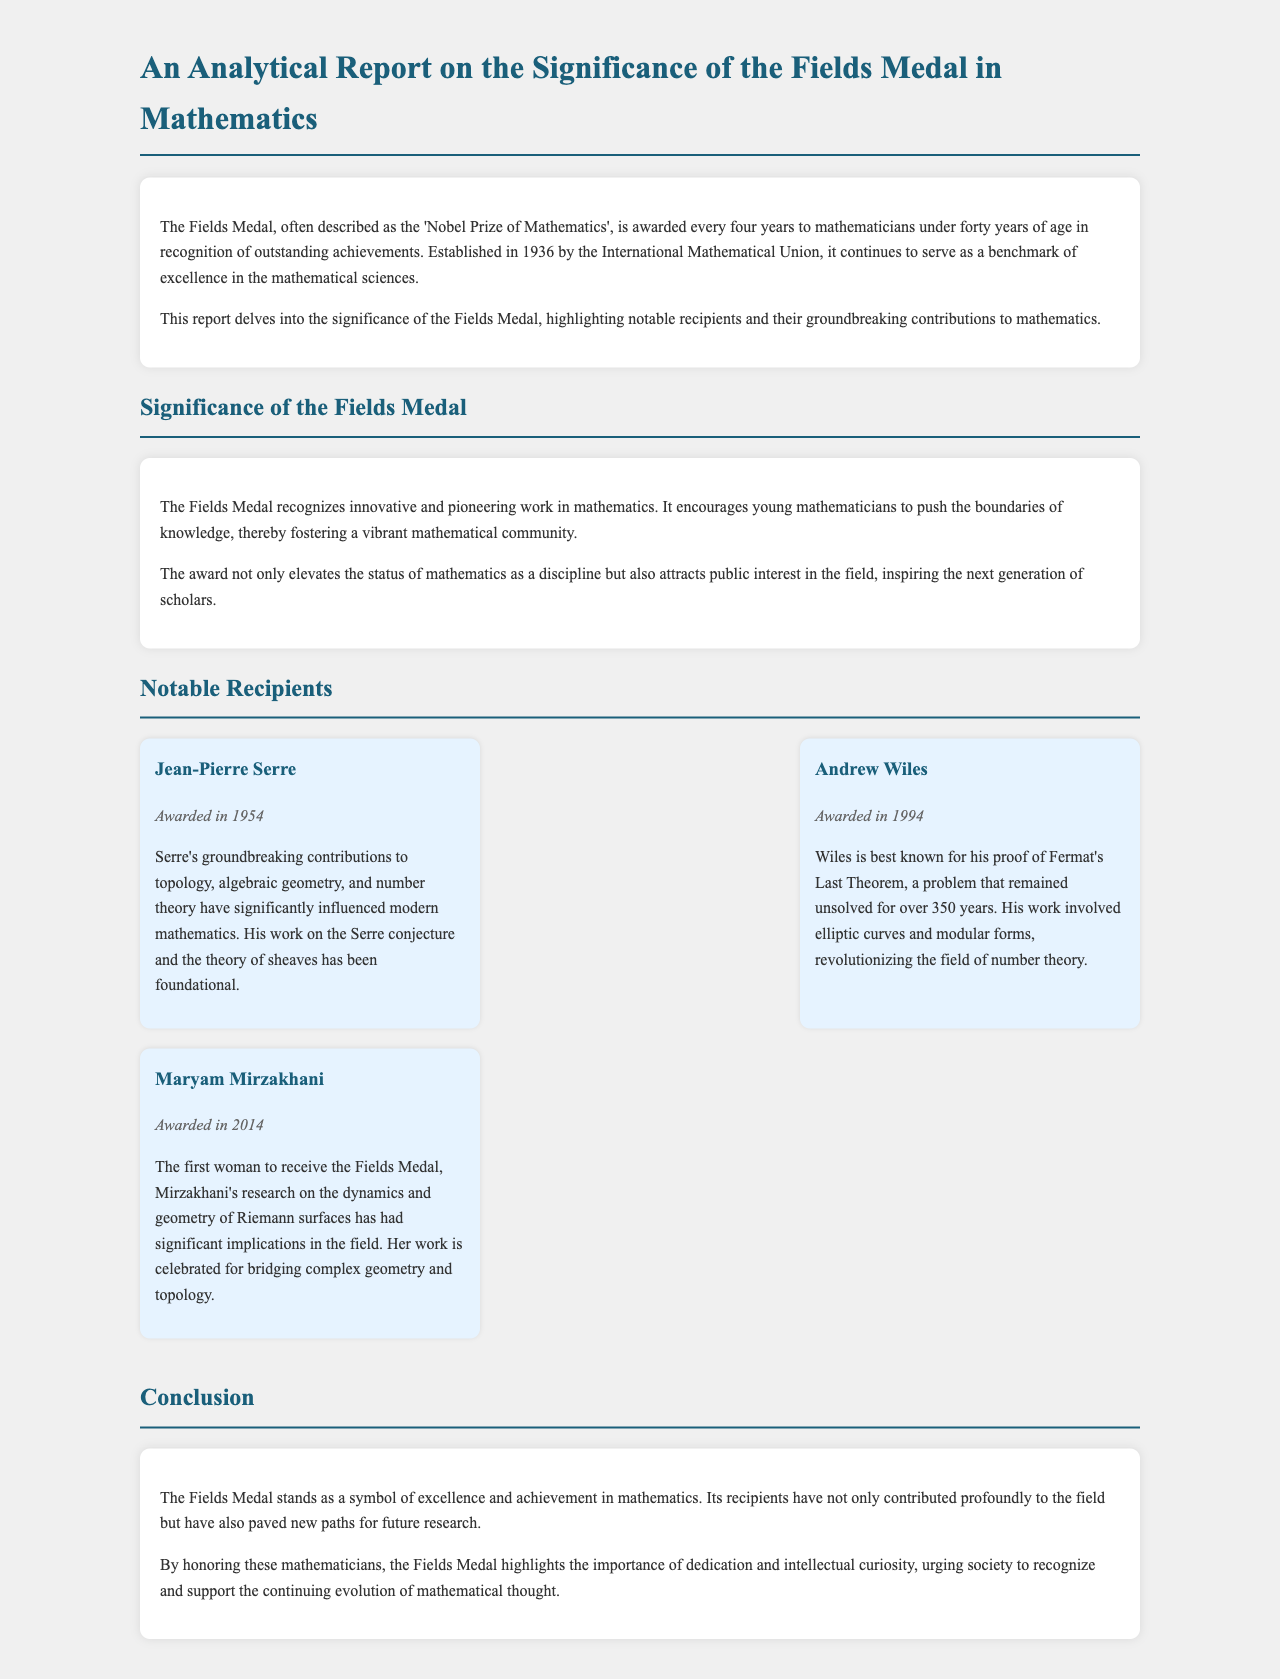what is the Fields Medal often described as? The Fields Medal is often described as the 'Nobel Prize of Mathematics'.
Answer: 'Nobel Prize of Mathematics' when is the Fields Medal awarded? The Fields Medal is awarded every four years.
Answer: every four years who received the Fields Medal in 2014? The recipient of the Fields Medal in 2014 was Maryam Mirzakhani.
Answer: Maryam Mirzakhani what problem did Andrew Wiles prove? Andrew Wiles is best known for his proof of Fermat's Last Theorem.
Answer: Fermat's Last Theorem what has the Fields Medal encouraged among young mathematicians? The Fields Medal encourages young mathematicians to push the boundaries of knowledge.
Answer: push the boundaries of knowledge how many recipients are highlighted in the report? The report highlights three notable recipients.
Answer: three which recipient's work is foundational in algebraic geometry? Jean-Pierre Serre’s work is foundational in algebraic geometry.
Answer: Jean-Pierre Serre what does the Fields Medal symbolize? The Fields Medal stands as a symbol of excellence and achievement in mathematics.
Answer: excellence and achievement in mathematics 